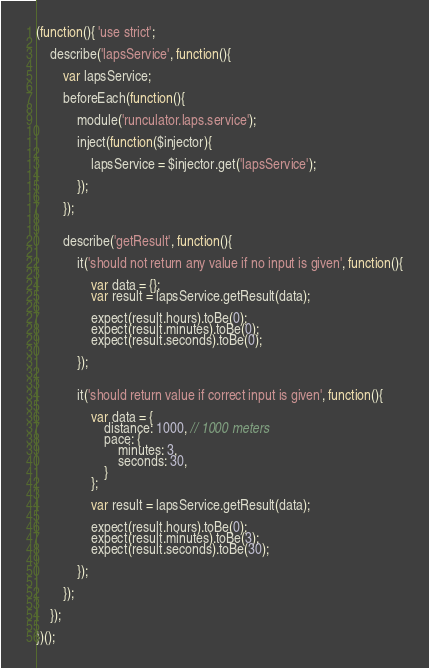<code> <loc_0><loc_0><loc_500><loc_500><_JavaScript_>(function(){ 'use strict';

	describe('lapsService', function(){

		var lapsService;

		beforeEach(function(){

			module('runculator.laps.service');

			inject(function($injector){

				lapsService = $injector.get('lapsService');

			});

		});


		describe('getResult', function(){

			it('should not return any value if no input is given', function(){

				var data = {};
				var result = lapsService.getResult(data);

				expect(result.hours).toBe(0);
				expect(result.minutes).toBe(0);
				expect(result.seconds).toBe(0);

			});


			it('should return value if correct input is given', function(){

				var data = {
					distance: 1000, // 1000 meters
					pace: {
						minutes: 3,
						seconds: 30, 
					}
				};

				var result = lapsService.getResult(data);

				expect(result.hours).toBe(0);
				expect(result.minutes).toBe(3);
				expect(result.seconds).toBe(30);

			});
			
		});

	});

})();</code> 